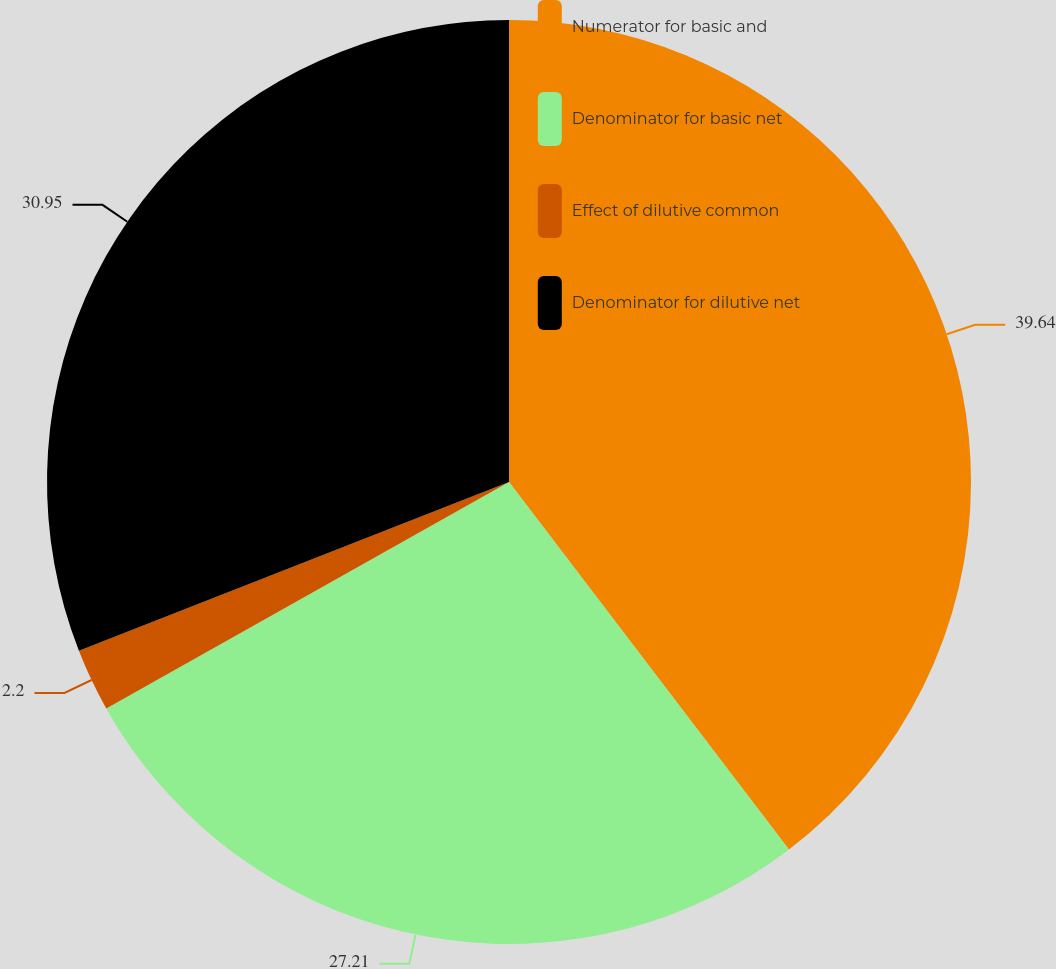Convert chart to OTSL. <chart><loc_0><loc_0><loc_500><loc_500><pie_chart><fcel>Numerator for basic and<fcel>Denominator for basic net<fcel>Effect of dilutive common<fcel>Denominator for dilutive net<nl><fcel>39.64%<fcel>27.21%<fcel>2.2%<fcel>30.95%<nl></chart> 